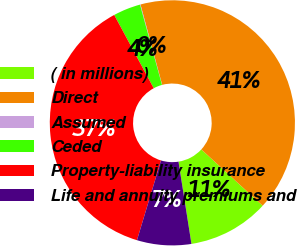<chart> <loc_0><loc_0><loc_500><loc_500><pie_chart><fcel>( in millions)<fcel>Direct<fcel>Assumed<fcel>Ceded<fcel>Property-liability insurance<fcel>Life and annuity premiums and<nl><fcel>10.69%<fcel>41.0%<fcel>0.07%<fcel>3.61%<fcel>37.46%<fcel>7.15%<nl></chart> 